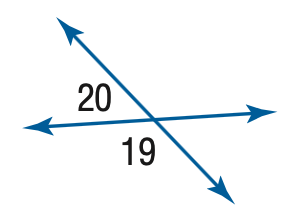Answer the mathemtical geometry problem and directly provide the correct option letter.
Question: m \angle 19 = 100 + 20 x, m \angle 20 = 20 x. Find the measure of \angle 19.
Choices: A: 100 B: 120 C: 140 D: 160 C 